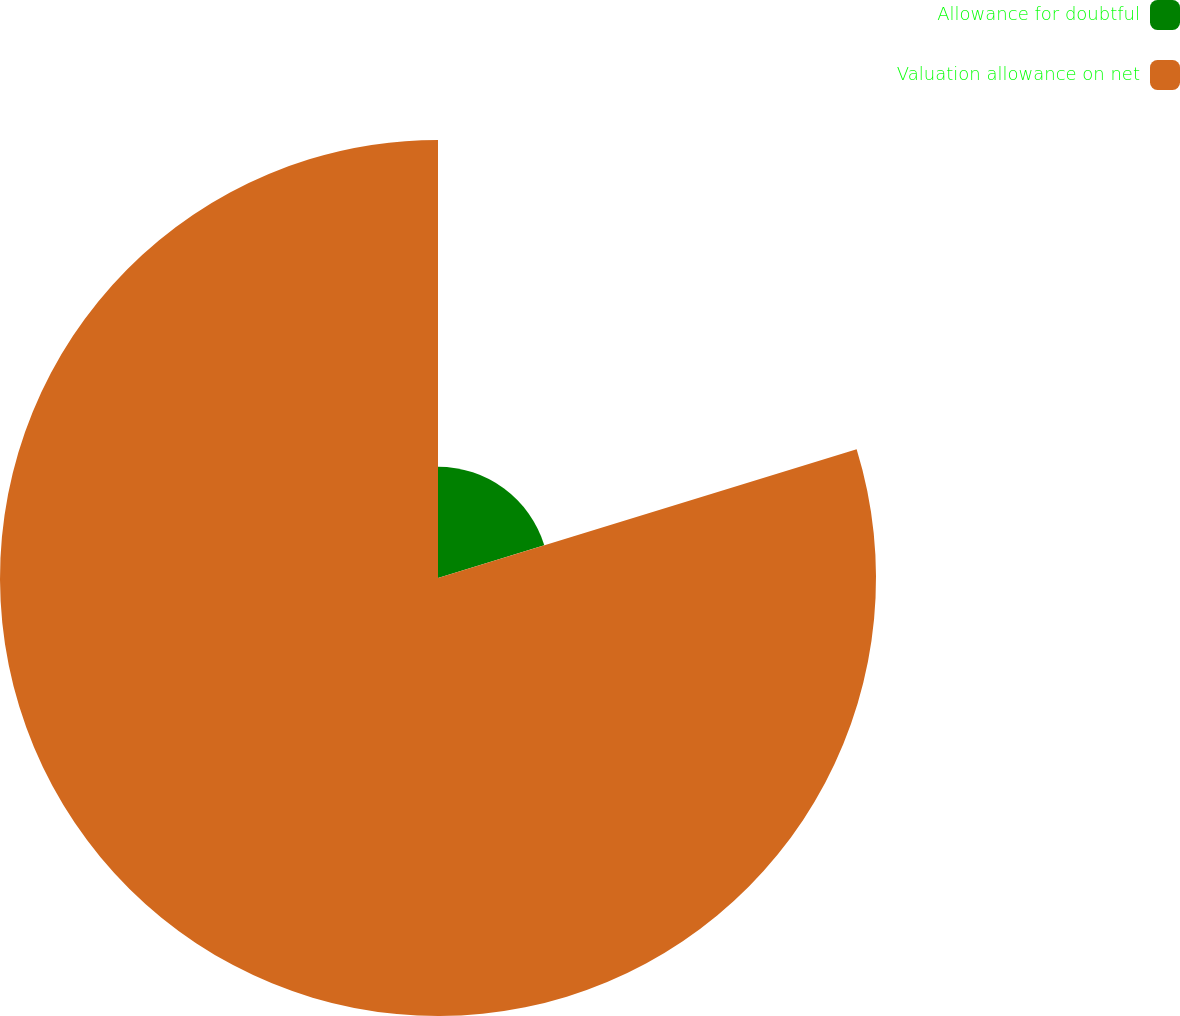Convert chart. <chart><loc_0><loc_0><loc_500><loc_500><pie_chart><fcel>Allowance for doubtful<fcel>Valuation allowance on net<nl><fcel>20.25%<fcel>79.75%<nl></chart> 